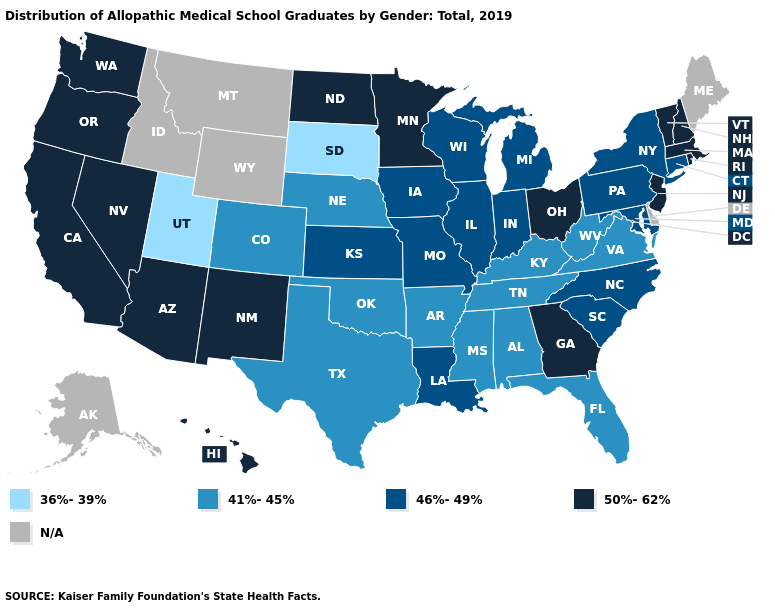Name the states that have a value in the range N/A?
Write a very short answer. Alaska, Delaware, Idaho, Maine, Montana, Wyoming. What is the lowest value in the West?
Concise answer only. 36%-39%. What is the value of Wyoming?
Keep it brief. N/A. Does the map have missing data?
Write a very short answer. Yes. Does the first symbol in the legend represent the smallest category?
Keep it brief. Yes. What is the highest value in the USA?
Give a very brief answer. 50%-62%. What is the highest value in states that border Washington?
Concise answer only. 50%-62%. Name the states that have a value in the range 50%-62%?
Give a very brief answer. Arizona, California, Georgia, Hawaii, Massachusetts, Minnesota, Nevada, New Hampshire, New Jersey, New Mexico, North Dakota, Ohio, Oregon, Rhode Island, Vermont, Washington. What is the value of New Jersey?
Answer briefly. 50%-62%. What is the value of Wisconsin?
Write a very short answer. 46%-49%. What is the highest value in states that border Pennsylvania?
Concise answer only. 50%-62%. Does Massachusetts have the highest value in the Northeast?
Answer briefly. Yes. 